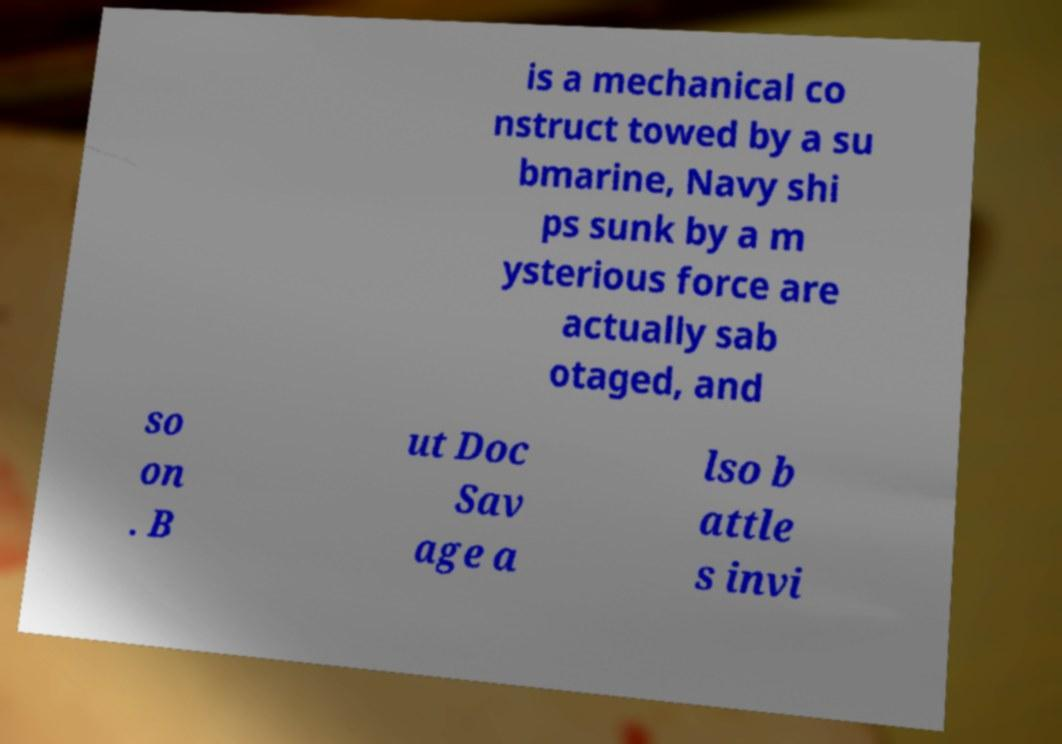What messages or text are displayed in this image? I need them in a readable, typed format. is a mechanical co nstruct towed by a su bmarine, Navy shi ps sunk by a m ysterious force are actually sab otaged, and so on . B ut Doc Sav age a lso b attle s invi 